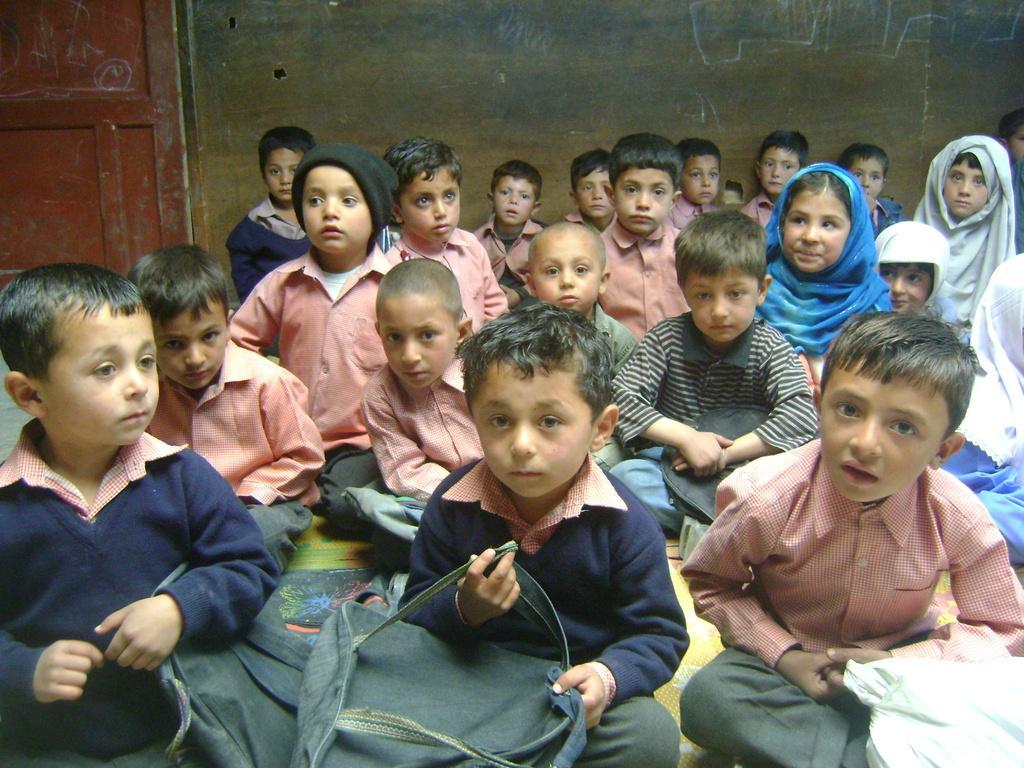Describe this image in one or two sentences. In this image I can see the group of people with different color dresses and few people with orange color dresses. I can see few people with the bags. In the background I can see the door and the wall. 